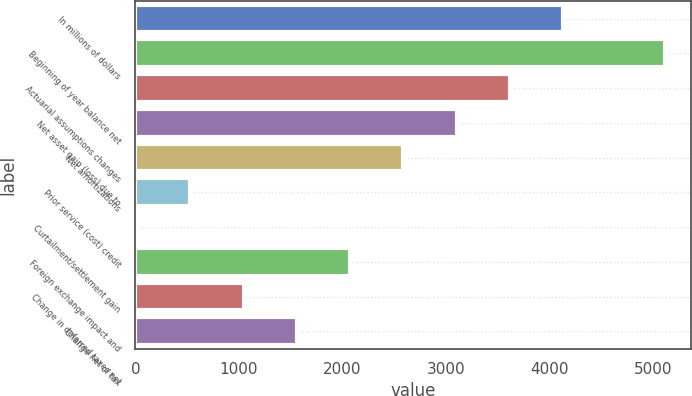Convert chart. <chart><loc_0><loc_0><loc_500><loc_500><bar_chart><fcel>In millions of dollars<fcel>Beginning of year balance net<fcel>Actuarial assumptions changes<fcel>Net asset gain (loss) due to<fcel>Net amortizations<fcel>Prior service (cost) credit<fcel>Curtailment/settlement gain<fcel>Foreign exchange impact and<fcel>Change in deferred taxes net<fcel>Change net of tax<nl><fcel>4134.6<fcel>5116<fcel>3619.9<fcel>3105.2<fcel>2590.5<fcel>531.7<fcel>17<fcel>2075.8<fcel>1046.4<fcel>1561.1<nl></chart> 